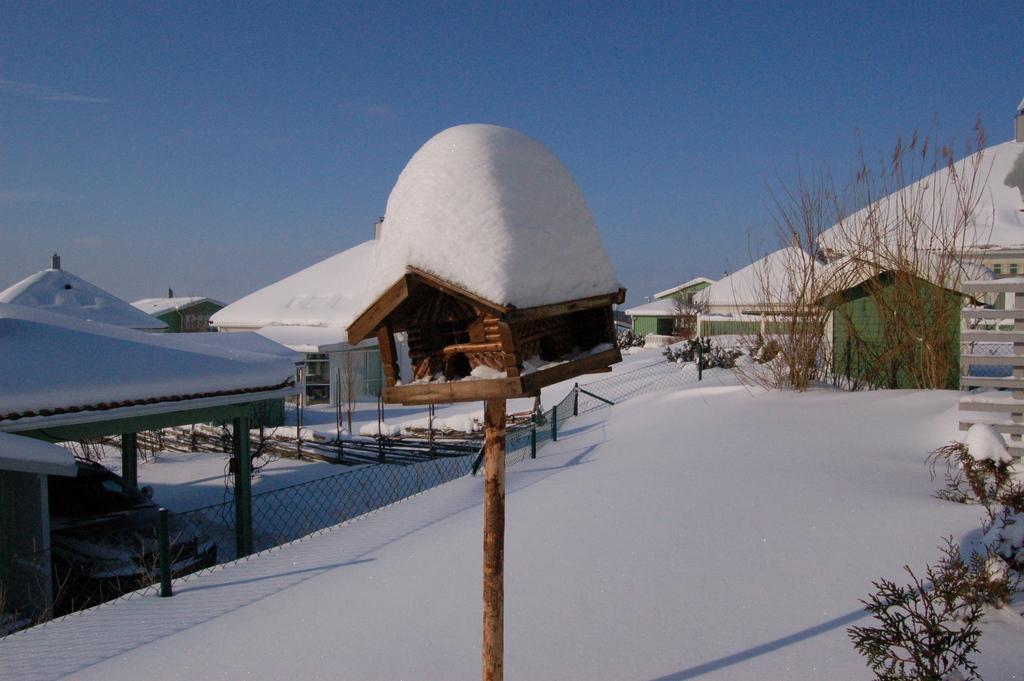Could you give a brief overview of what you see in this image? In this image, we can see sheds, poles are all covered by snow and there are plants and we can see a car, a fence and logs. At the bottom, there is snow and at the top, there is sky. 